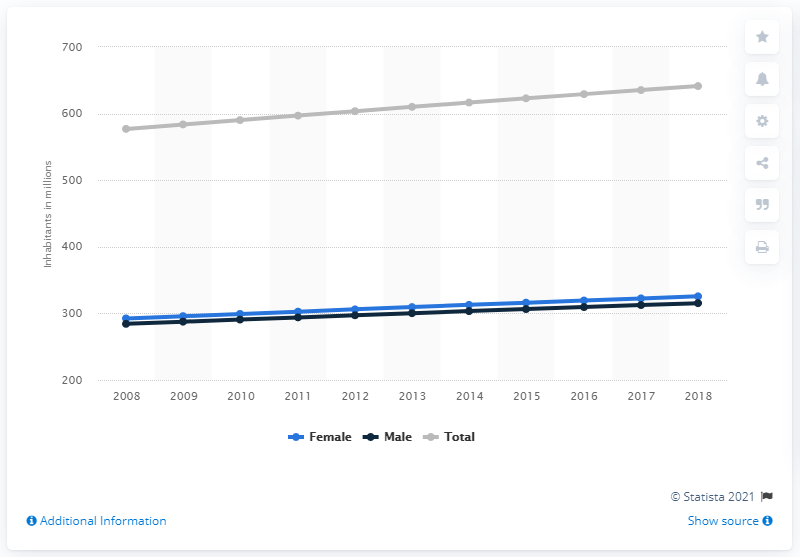List a handful of essential elements in this visual. The Latin American and Caribbean population has been increasing since 2008. In 2018, an estimated 325.64 million women lived in Latin America and the Caribbean. In 2018, an estimated 641.36 million people lived in Latin America and the Caribbean. 